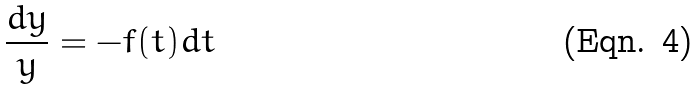<formula> <loc_0><loc_0><loc_500><loc_500>\frac { d y } { y } = - f ( t ) d t</formula> 